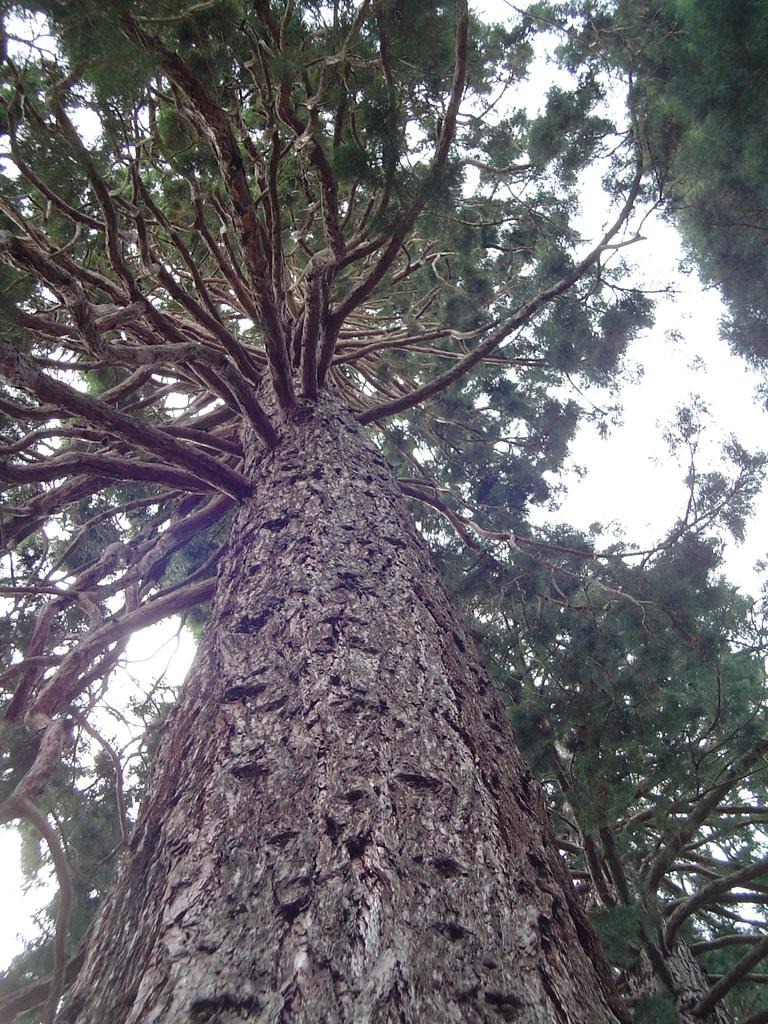What type of vegetation can be seen in the image? There are trees in the image. What part of the natural environment is visible in the image? The sky is visible in the image. Can you see a fan in the image? There is no fan present in the image. Is there a hen visible in the image? There is no hen present in the image. Is there a match in the image? There is no match present in the image. 